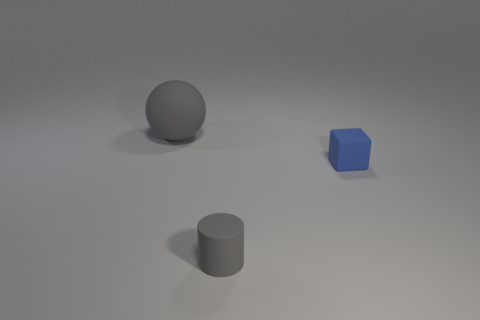There is a gray object to the right of the gray sphere; what is its shape?
Your response must be concise. Cylinder. Do the small gray cylinder and the large object have the same material?
Provide a short and direct response. Yes. Is there anything else that has the same material as the tiny cylinder?
Provide a short and direct response. Yes. Are there fewer tiny blue blocks on the left side of the cylinder than matte cylinders?
Offer a terse response. Yes. There is a tiny matte cylinder; what number of small blue rubber cubes are to the left of it?
Your response must be concise. 0. There is a object left of the small gray rubber thing; is it the same shape as the thing that is to the right of the small gray object?
Your answer should be compact. No. What is the shape of the matte object that is both behind the tiny gray rubber object and in front of the big gray sphere?
Your answer should be very brief. Cube. The gray object that is made of the same material as the gray cylinder is what size?
Make the answer very short. Large. Is the number of tiny blue cubes less than the number of rubber objects?
Provide a short and direct response. Yes. There is a thing that is right of the gray rubber object that is to the right of the rubber thing behind the small blue cube; what is it made of?
Provide a succinct answer. Rubber. 